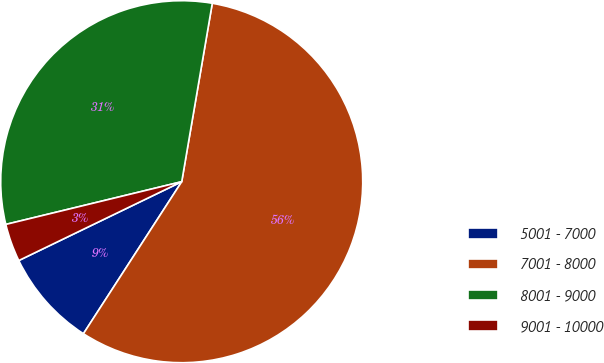Convert chart to OTSL. <chart><loc_0><loc_0><loc_500><loc_500><pie_chart><fcel>5001 - 7000<fcel>7001 - 8000<fcel>8001 - 9000<fcel>9001 - 10000<nl><fcel>8.69%<fcel>56.43%<fcel>31.49%<fcel>3.38%<nl></chart> 